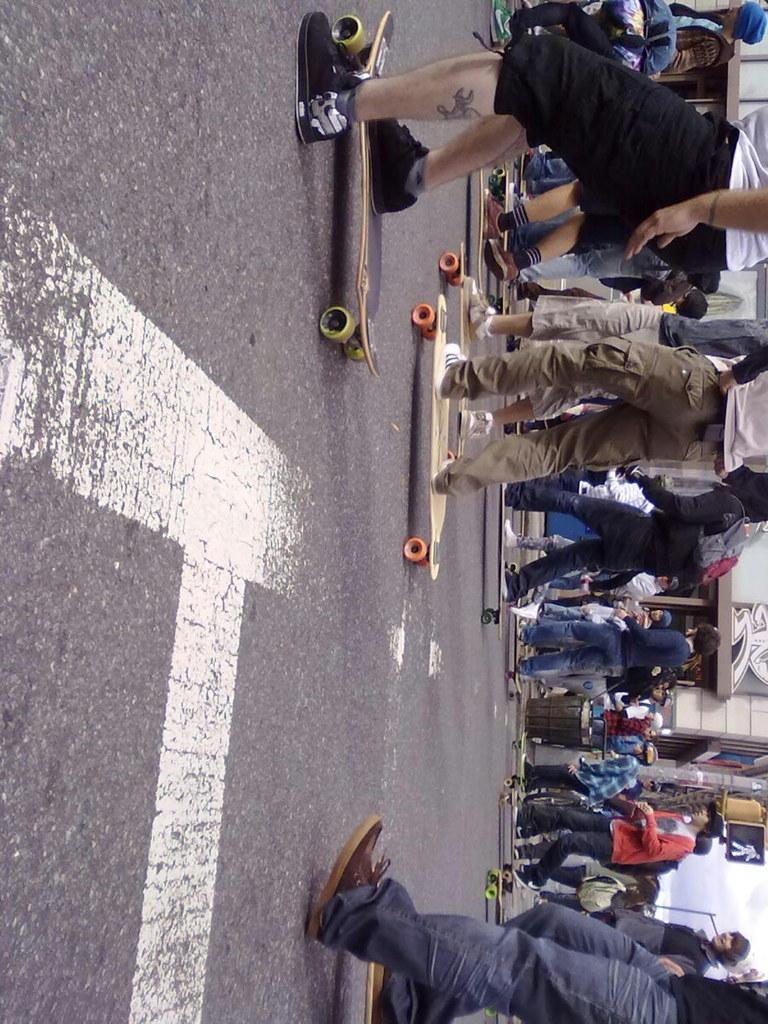How many people are in the image? There is a group of people in the image. What activity are the people engaged in? The people are skating on the road. What type of leather is being used by the girls in the image? There are no girls or leather mentioned in the image; it only features a group of people skating on the road. 